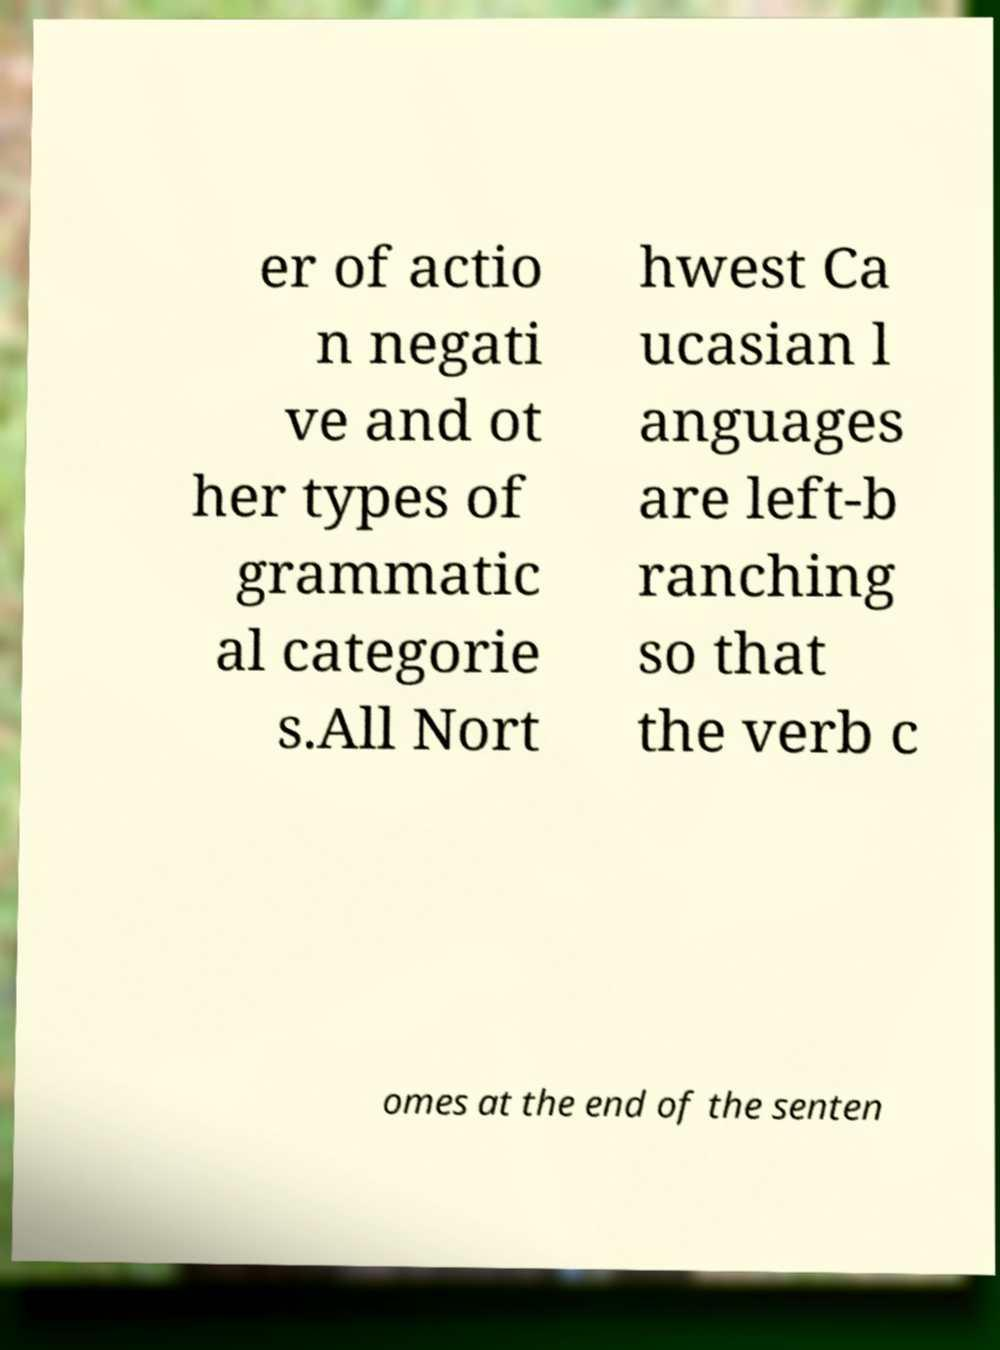Can you accurately transcribe the text from the provided image for me? er of actio n negati ve and ot her types of grammatic al categorie s.All Nort hwest Ca ucasian l anguages are left-b ranching so that the verb c omes at the end of the senten 